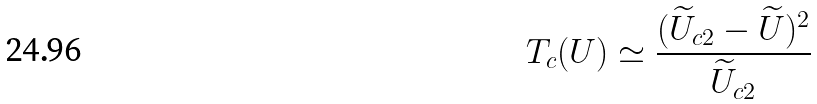Convert formula to latex. <formula><loc_0><loc_0><loc_500><loc_500>T _ { c } ( U ) \simeq \frac { ( \widetilde { U } _ { c 2 } - \widetilde { U } ) ^ { 2 } } { \widetilde { U } _ { c 2 } }</formula> 